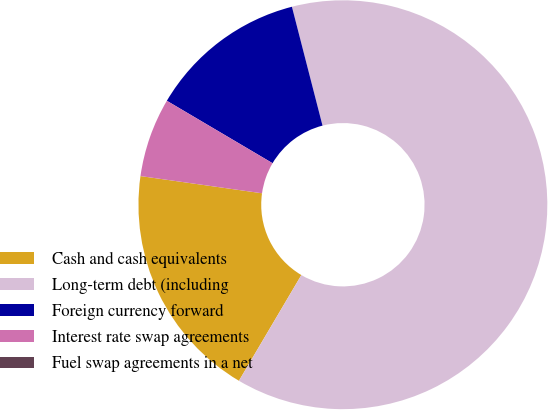<chart> <loc_0><loc_0><loc_500><loc_500><pie_chart><fcel>Cash and cash equivalents<fcel>Long-term debt (including<fcel>Foreign currency forward<fcel>Interest rate swap agreements<fcel>Fuel swap agreements in a net<nl><fcel>18.75%<fcel>62.5%<fcel>12.5%<fcel>6.25%<fcel>0.0%<nl></chart> 